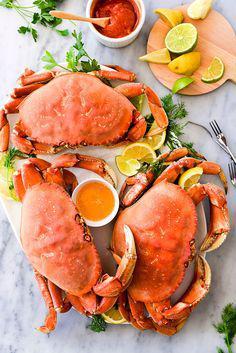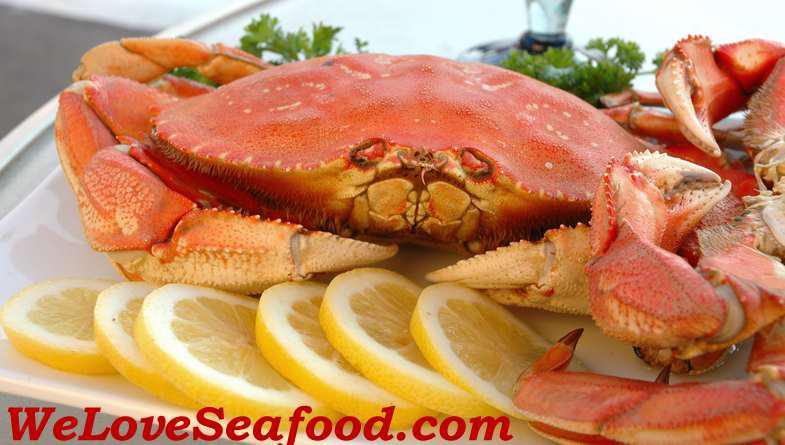The first image is the image on the left, the second image is the image on the right. For the images displayed, is the sentence "In one image the entire crab is left intact, while the other image shows only pieces of a crab on a plate." factually correct? Answer yes or no. No. The first image is the image on the left, the second image is the image on the right. Considering the images on both sides, is "The crabs in each of the images are sitting in a round white plate." valid? Answer yes or no. No. 